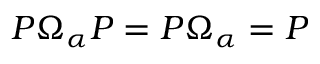Convert formula to latex. <formula><loc_0><loc_0><loc_500><loc_500>P \Omega _ { \alpha } P = P \Omega _ { \alpha } = P</formula> 